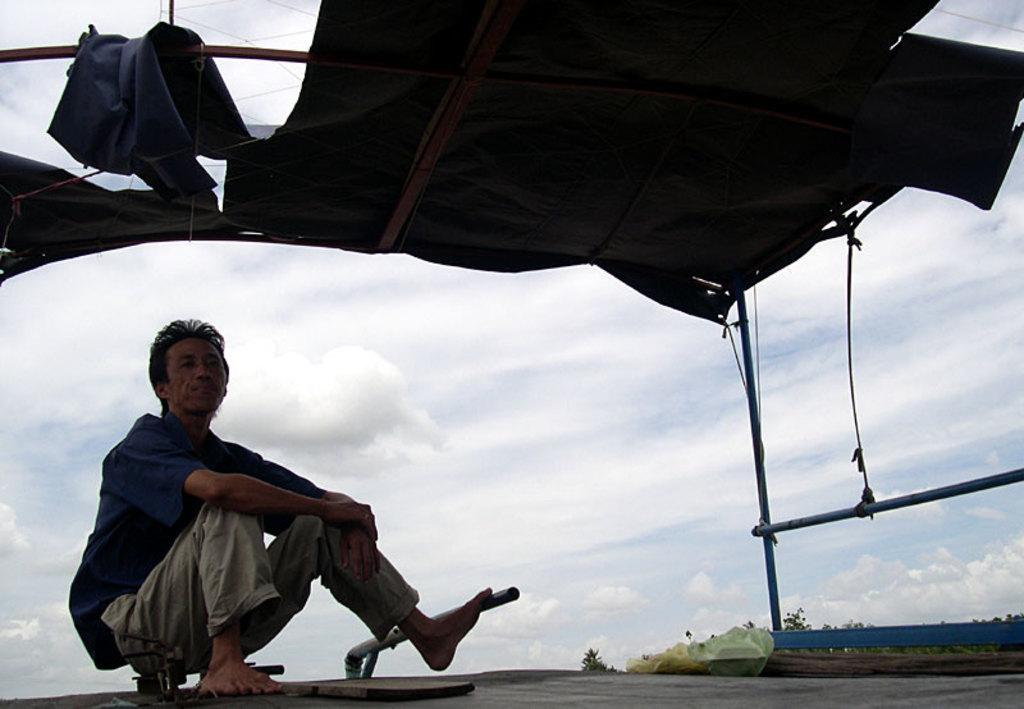Describe this image in one or two sentences. In this image we can see a person sitting under the black color tint. In the background we can see a cloudy sky. Trees are also visible in this image. 